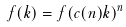<formula> <loc_0><loc_0><loc_500><loc_500>f ( k ) = f ( c ( n ) k ) ^ { n }</formula> 